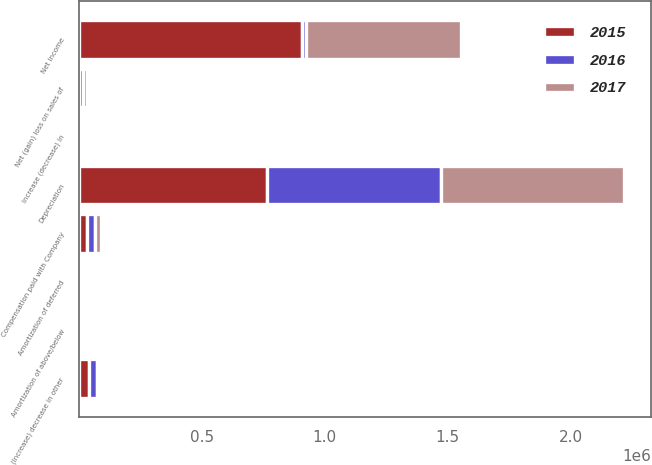<chart> <loc_0><loc_0><loc_500><loc_500><stacked_bar_chart><ecel><fcel>Net income<fcel>Depreciation<fcel>Amortization of deferred<fcel>Amortization of above/below<fcel>Net (gain) loss on sales of<fcel>Compensation paid with Company<fcel>(Increase) decrease in other<fcel>Increase (decrease) in<nl><fcel>2017<fcel>628381<fcel>743749<fcel>8526<fcel>3828<fcel>19167<fcel>24997<fcel>449<fcel>11532<nl><fcel>2016<fcel>15731<fcel>705649<fcel>12633<fcel>3426<fcel>15731<fcel>30530<fcel>31147<fcel>6061<nl><fcel>2015<fcel>908018<fcel>765895<fcel>10801<fcel>3382<fcel>1<fcel>34607<fcel>41803<fcel>1667<nl></chart> 